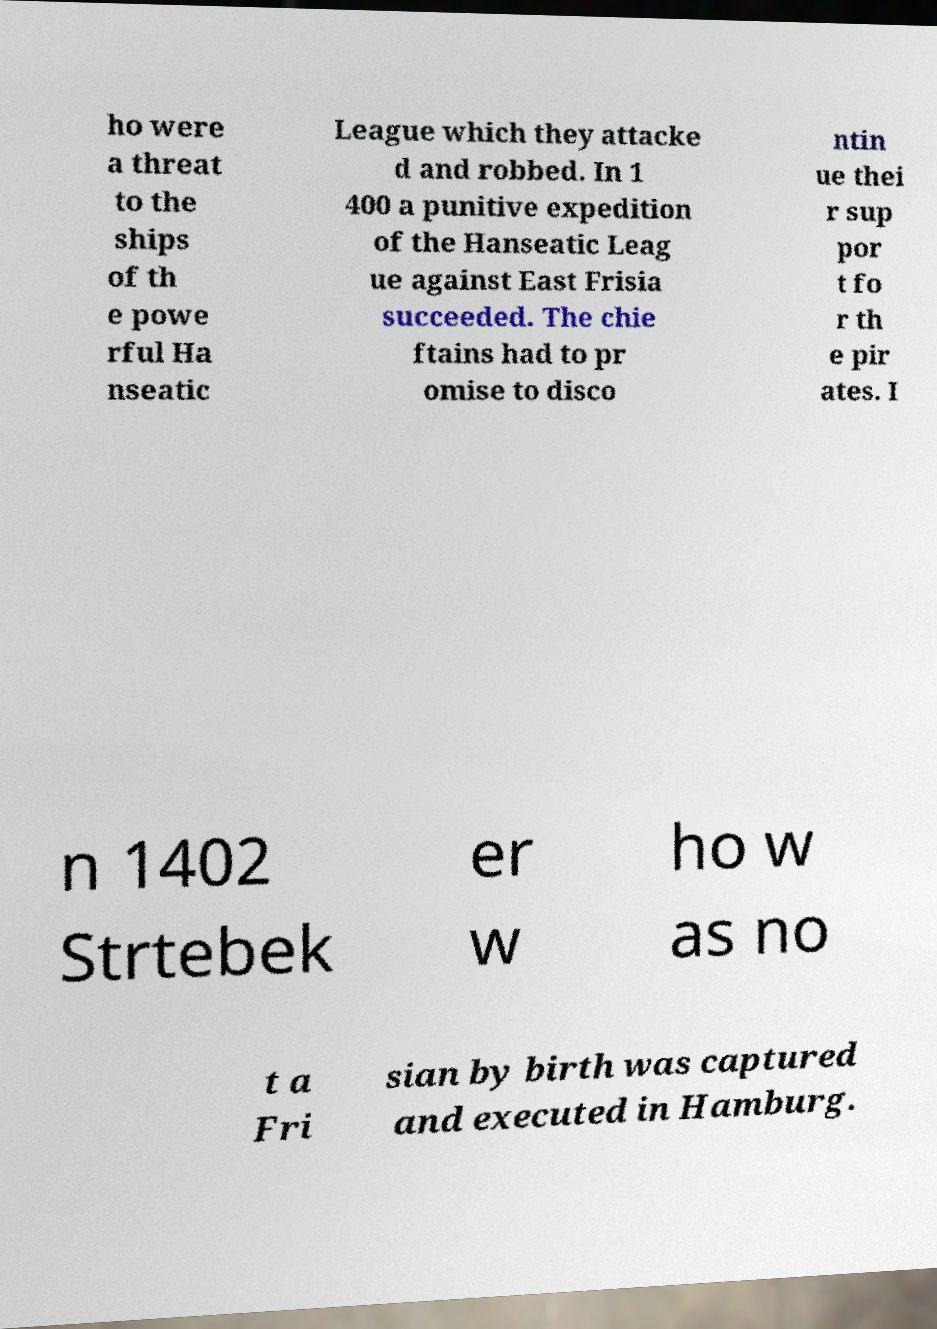Can you accurately transcribe the text from the provided image for me? ho were a threat to the ships of th e powe rful Ha nseatic League which they attacke d and robbed. In 1 400 a punitive expedition of the Hanseatic Leag ue against East Frisia succeeded. The chie ftains had to pr omise to disco ntin ue thei r sup por t fo r th e pir ates. I n 1402 Strtebek er w ho w as no t a Fri sian by birth was captured and executed in Hamburg. 